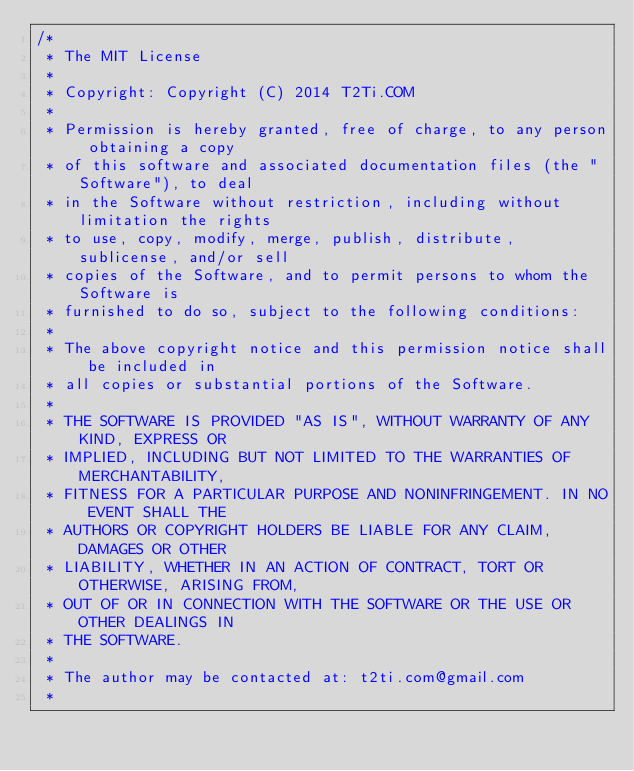<code> <loc_0><loc_0><loc_500><loc_500><_Java_>/*
 * The MIT License
 * 
 * Copyright: Copyright (C) 2014 T2Ti.COM
 * 
 * Permission is hereby granted, free of charge, to any person obtaining a copy
 * of this software and associated documentation files (the "Software"), to deal
 * in the Software without restriction, including without limitation the rights
 * to use, copy, modify, merge, publish, distribute, sublicense, and/or sell
 * copies of the Software, and to permit persons to whom the Software is
 * furnished to do so, subject to the following conditions:
 * 
 * The above copyright notice and this permission notice shall be included in
 * all copies or substantial portions of the Software.
 * 
 * THE SOFTWARE IS PROVIDED "AS IS", WITHOUT WARRANTY OF ANY KIND, EXPRESS OR
 * IMPLIED, INCLUDING BUT NOT LIMITED TO THE WARRANTIES OF MERCHANTABILITY,
 * FITNESS FOR A PARTICULAR PURPOSE AND NONINFRINGEMENT. IN NO EVENT SHALL THE
 * AUTHORS OR COPYRIGHT HOLDERS BE LIABLE FOR ANY CLAIM, DAMAGES OR OTHER
 * LIABILITY, WHETHER IN AN ACTION OF CONTRACT, TORT OR OTHERWISE, ARISING FROM,
 * OUT OF OR IN CONNECTION WITH THE SOFTWARE OR THE USE OR OTHER DEALINGS IN
 * THE SOFTWARE.
 * 
 * The author may be contacted at: t2ti.com@gmail.com
 *</code> 